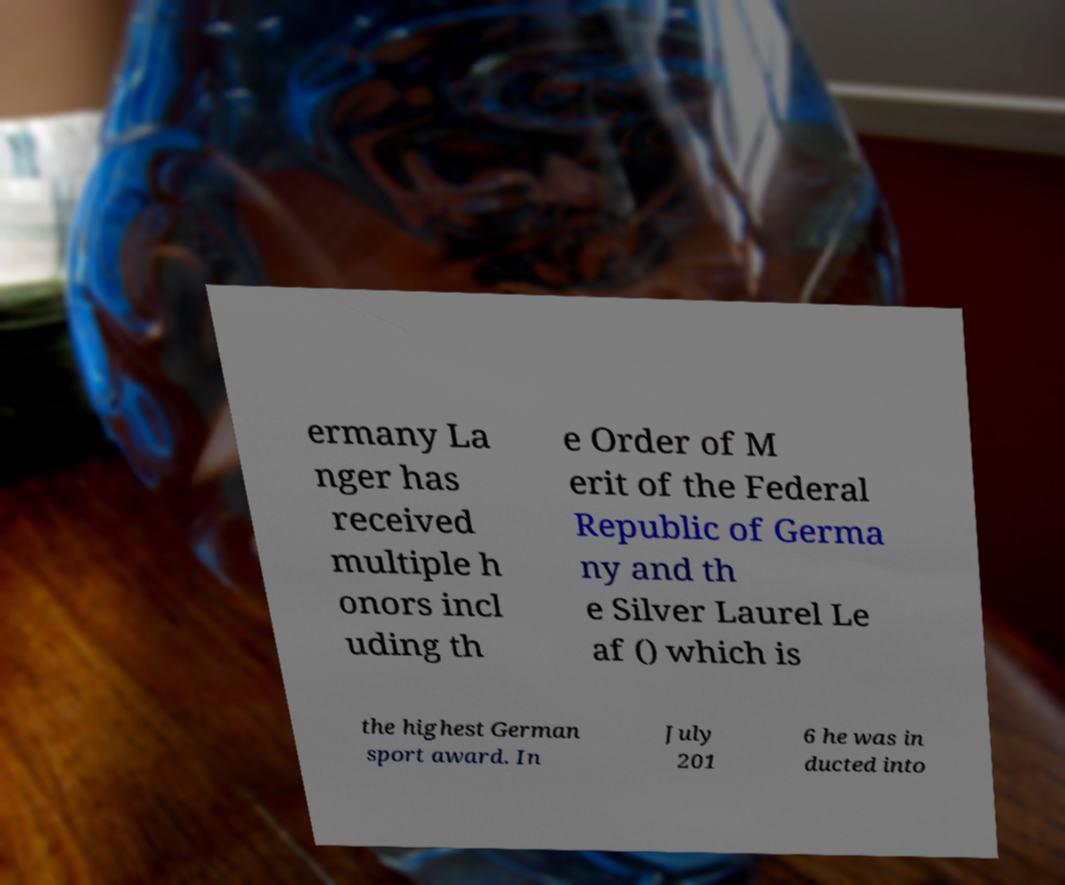Can you read and provide the text displayed in the image?This photo seems to have some interesting text. Can you extract and type it out for me? ermany La nger has received multiple h onors incl uding th e Order of M erit of the Federal Republic of Germa ny and th e Silver Laurel Le af () which is the highest German sport award. In July 201 6 he was in ducted into 